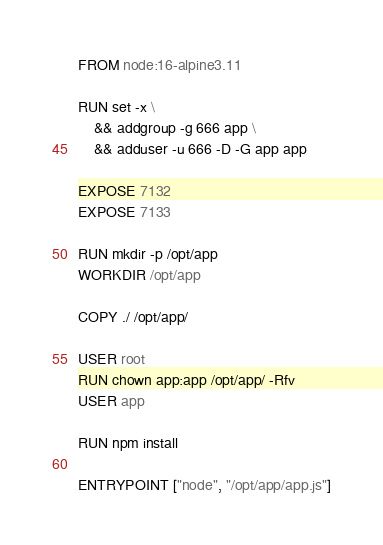<code> <loc_0><loc_0><loc_500><loc_500><_Dockerfile_>FROM node:16-alpine3.11

RUN set -x \
    && addgroup -g 666 app \
    && adduser -u 666 -D -G app app

EXPOSE 7132
EXPOSE 7133

RUN mkdir -p /opt/app
WORKDIR /opt/app

COPY ./ /opt/app/

USER root
RUN chown app:app /opt/app/ -Rfv
USER app

RUN npm install

ENTRYPOINT ["node", "/opt/app/app.js"]
</code> 